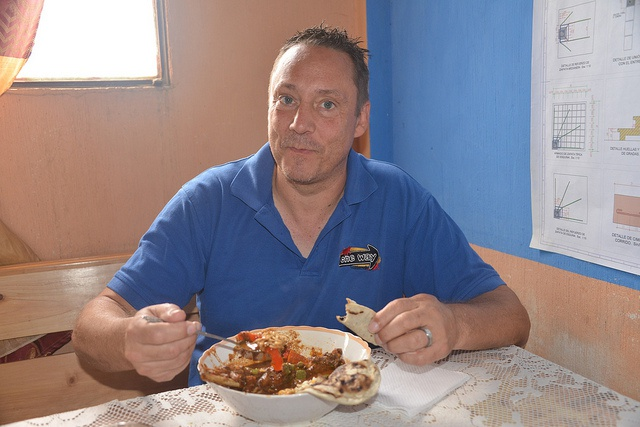Describe the objects in this image and their specific colors. I can see people in brown, darkblue, gray, and blue tones, dining table in brown, darkgray, lightgray, and gray tones, bowl in brown, darkgray, maroon, and tan tones, and spoon in brown, gray, and darkgray tones in this image. 